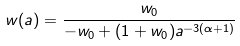<formula> <loc_0><loc_0><loc_500><loc_500>w ( a ) = \frac { w _ { 0 } } { - w _ { 0 } + ( 1 + w _ { 0 } ) { a ^ { - 3 ( \alpha + 1 ) } } }</formula> 